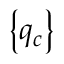<formula> <loc_0><loc_0><loc_500><loc_500>\left \{ q _ { c } \right \}</formula> 